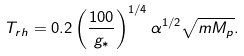Convert formula to latex. <formula><loc_0><loc_0><loc_500><loc_500>T _ { r h } = 0 . 2 \left ( \frac { 1 0 0 } { g _ { * } } \right ) ^ { 1 / 4 } \alpha ^ { 1 / 2 } \sqrt { m M _ { p } } .</formula> 